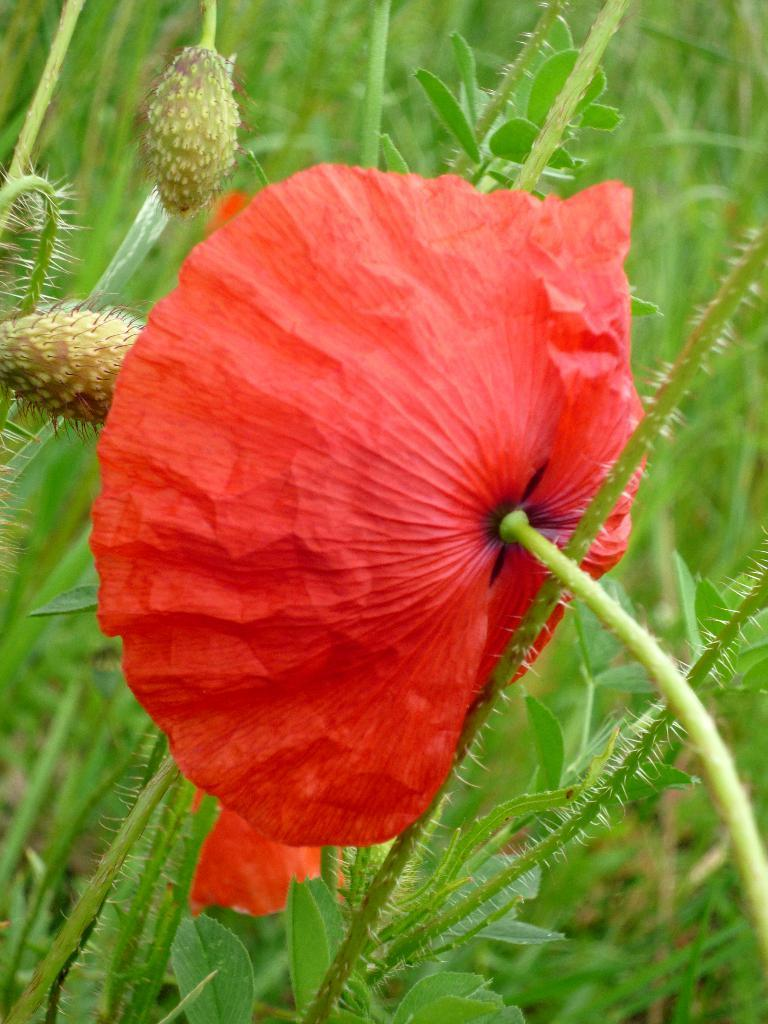What color is the flower in the image? The flower in the image is red. What is the flower attached to? The flower is attached to a green plant. What can be seen in the background of the image? There are 2 buds and green plants in the background of the image. What type of bubble is being used to water the red flower in the image? There is no bubble present in the image, and the red flower is not being watered. 